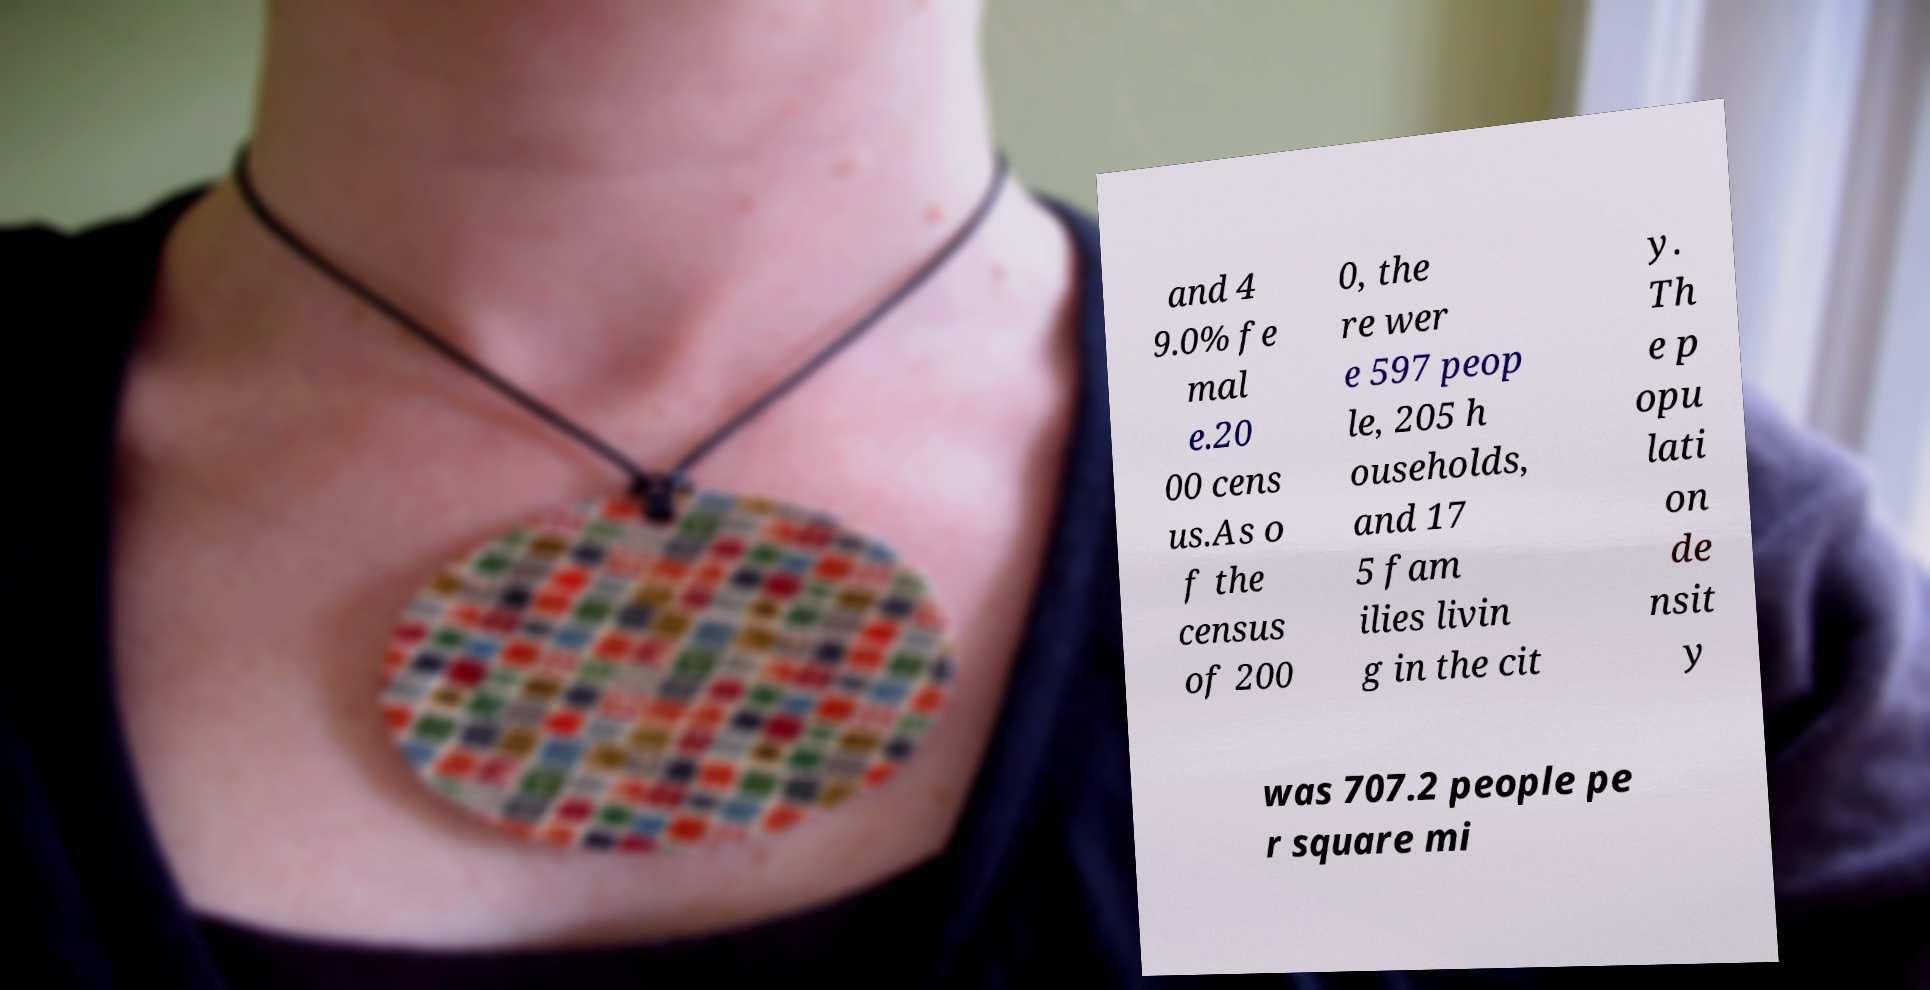Can you read and provide the text displayed in the image?This photo seems to have some interesting text. Can you extract and type it out for me? and 4 9.0% fe mal e.20 00 cens us.As o f the census of 200 0, the re wer e 597 peop le, 205 h ouseholds, and 17 5 fam ilies livin g in the cit y. Th e p opu lati on de nsit y was 707.2 people pe r square mi 